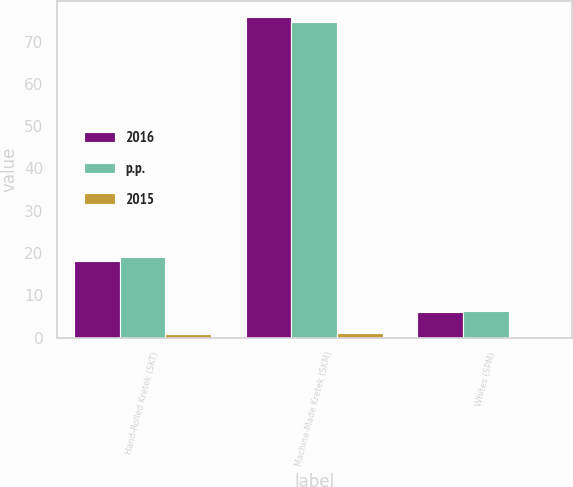Convert chart. <chart><loc_0><loc_0><loc_500><loc_500><stacked_bar_chart><ecel><fcel>Hand-Rolled Kretek (SKT)<fcel>Machine-Made Kretek (SKM)<fcel>Whites (SPM)<nl><fcel>2016<fcel>18.2<fcel>75.8<fcel>6<nl><fcel>p.p.<fcel>19.1<fcel>74.7<fcel>6.2<nl><fcel>2015<fcel>0.9<fcel>1.1<fcel>0.2<nl></chart> 